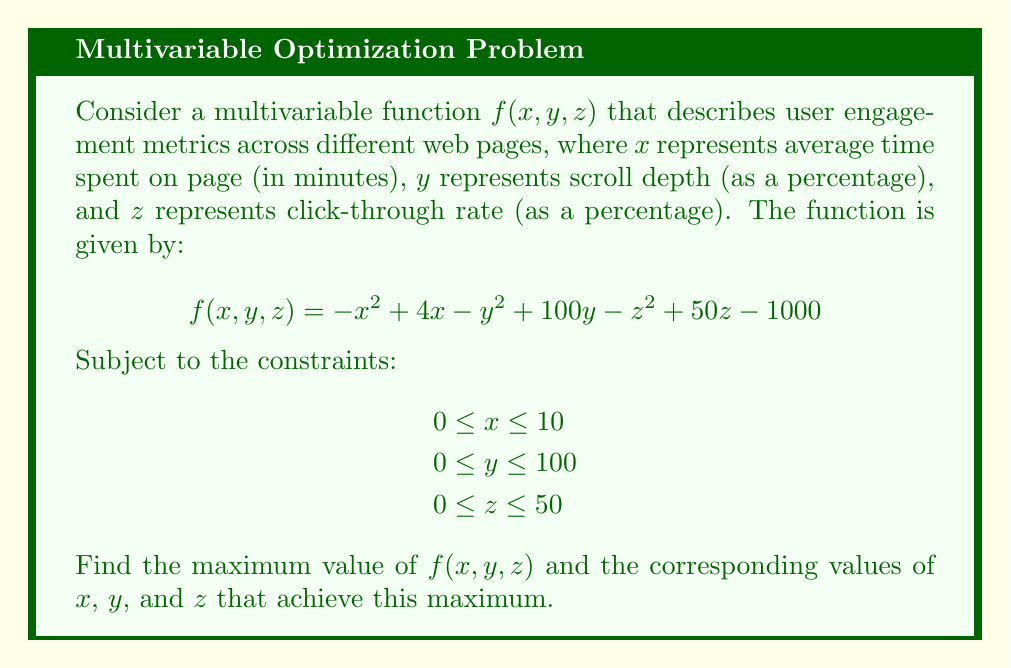Teach me how to tackle this problem. To find the maximum value of the multivariable function $f(x, y, z)$, we'll follow these steps:

1) First, we need to find the critical points by taking partial derivatives and setting them equal to zero:

   $\frac{\partial f}{\partial x} = -2x + 4 = 0$
   $\frac{\partial f}{\partial y} = -2y + 100 = 0$
   $\frac{\partial f}{\partial z} = -2z + 50 = 0$

2) Solving these equations:
   $x = 2$
   $y = 50$
   $z = 25$

3) Now we need to check if this critical point $(2, 50, 25)$ is within our constraints:
   $0 \leq 2 \leq 10$ (True)
   $0 \leq 50 \leq 100$ (True)
   $0 \leq 25 \leq 50$ (True)

   The critical point is within the constraints.

4) To confirm this is a maximum, we can check the second partial derivatives:
   $\frac{\partial^2 f}{\partial x^2} = -2$
   $\frac{\partial^2 f}{\partial y^2} = -2$
   $\frac{\partial^2 f}{\partial z^2} = -2$

   All second partial derivatives are negative, confirming this is a local maximum.

5) We also need to check the boundaries of our constraints. The function is quadratic in each variable with a negative coefficient for the squared term, so the maximum on any boundary will occur at an endpoint.

6) Evaluating $f$ at the critical point:
   $f(2, 50, 25) = (-4 + 8) + (-2500 + 5000) + (-625 + 1250) - 1000 = 2129$

7) The maximum possible values at the boundaries are:
   $f(10, 50, 25) = 2029$
   $f(2, 100, 25) = 2129$
   $f(2, 50, 50) = 2104$

Therefore, the global maximum occurs at the critical point $(2, 50, 25)$.
Answer: The maximum value of $f(x, y, z)$ is 2129, occurring at $x = 2$, $y = 50$, and $z = 25$. 